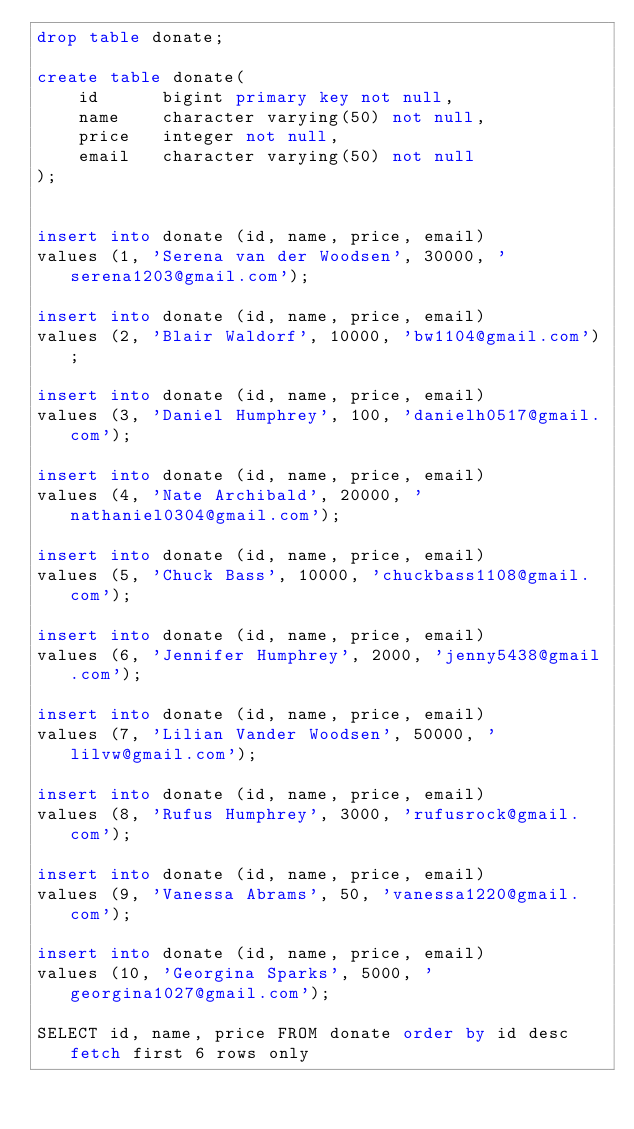Convert code to text. <code><loc_0><loc_0><loc_500><loc_500><_SQL_>drop table donate;

create table donate(
	id 		bigint primary key not null,
	name	character varying(50) not null,
	price	integer not null,
	email	character varying(50) not null
);


insert into donate (id, name, price, email)
values (1, 'Serena van der Woodsen', 30000, 'serena1203@gmail.com');

insert into donate (id, name, price, email)
values (2, 'Blair Waldorf', 10000, 'bw1104@gmail.com');

insert into donate (id, name, price, email)
values (3, 'Daniel Humphrey', 100, 'danielh0517@gmail.com');

insert into donate (id, name, price, email)
values (4, 'Nate Archibald', 20000, 'nathaniel0304@gmail.com');

insert into donate (id, name, price, email)
values (5, 'Chuck Bass', 10000, 'chuckbass1108@gmail.com');

insert into donate (id, name, price, email)
values (6, 'Jennifer Humphrey', 2000, 'jenny5438@gmail.com');

insert into donate (id, name, price, email)
values (7, 'Lilian Vander Woodsen', 50000, 'lilvw@gmail.com');

insert into donate (id, name, price, email)
values (8, 'Rufus Humphrey', 3000, 'rufusrock@gmail.com');

insert into donate (id, name, price, email)
values (9, 'Vanessa Abrams', 50, 'vanessa1220@gmail.com');

insert into donate (id, name, price, email)
values (10, 'Georgina Sparks', 5000, 'georgina1027@gmail.com');

SELECT id, name, price FROM donate order by id desc fetch first 6 rows only
</code> 